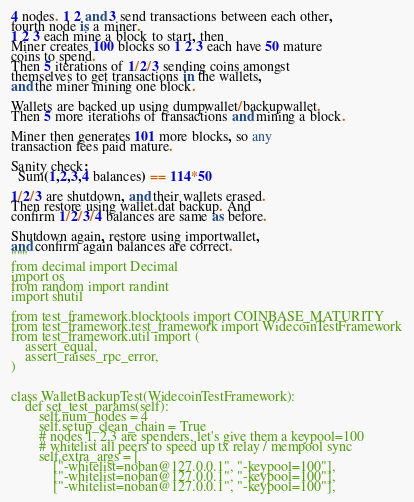<code> <loc_0><loc_0><loc_500><loc_500><_Python_>4 nodes. 1 2 and 3 send transactions between each other,
fourth node is a miner.
1 2 3 each mine a block to start, then
Miner creates 100 blocks so 1 2 3 each have 50 mature
coins to spend.
Then 5 iterations of 1/2/3 sending coins amongst
themselves to get transactions in the wallets,
and the miner mining one block.

Wallets are backed up using dumpwallet/backupwallet.
Then 5 more iterations of transactions and mining a block.

Miner then generates 101 more blocks, so any
transaction fees paid mature.

Sanity check:
  Sum(1,2,3,4 balances) == 114*50

1/2/3 are shutdown, and their wallets erased.
Then restore using wallet.dat backup. And
confirm 1/2/3/4 balances are same as before.

Shutdown again, restore using importwallet,
and confirm again balances are correct.
"""
from decimal import Decimal
import os
from random import randint
import shutil

from test_framework.blocktools import COINBASE_MATURITY
from test_framework.test_framework import WidecoinTestFramework
from test_framework.util import (
    assert_equal,
    assert_raises_rpc_error,
)


class WalletBackupTest(WidecoinTestFramework):
    def set_test_params(self):
        self.num_nodes = 4
        self.setup_clean_chain = True
        # nodes 1, 2,3 are spenders, let's give them a keypool=100
        # whitelist all peers to speed up tx relay / mempool sync
        self.extra_args = [
            ["-whitelist=noban@127.0.0.1", "-keypool=100"],
            ["-whitelist=noban@127.0.0.1", "-keypool=100"],
            ["-whitelist=noban@127.0.0.1", "-keypool=100"],</code> 